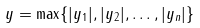Convert formula to latex. <formula><loc_0><loc_0><loc_500><loc_500>\| \ y \| = \max \{ | y _ { 1 } | , | y _ { 2 } | , \dots , | y _ { n } | \}</formula> 